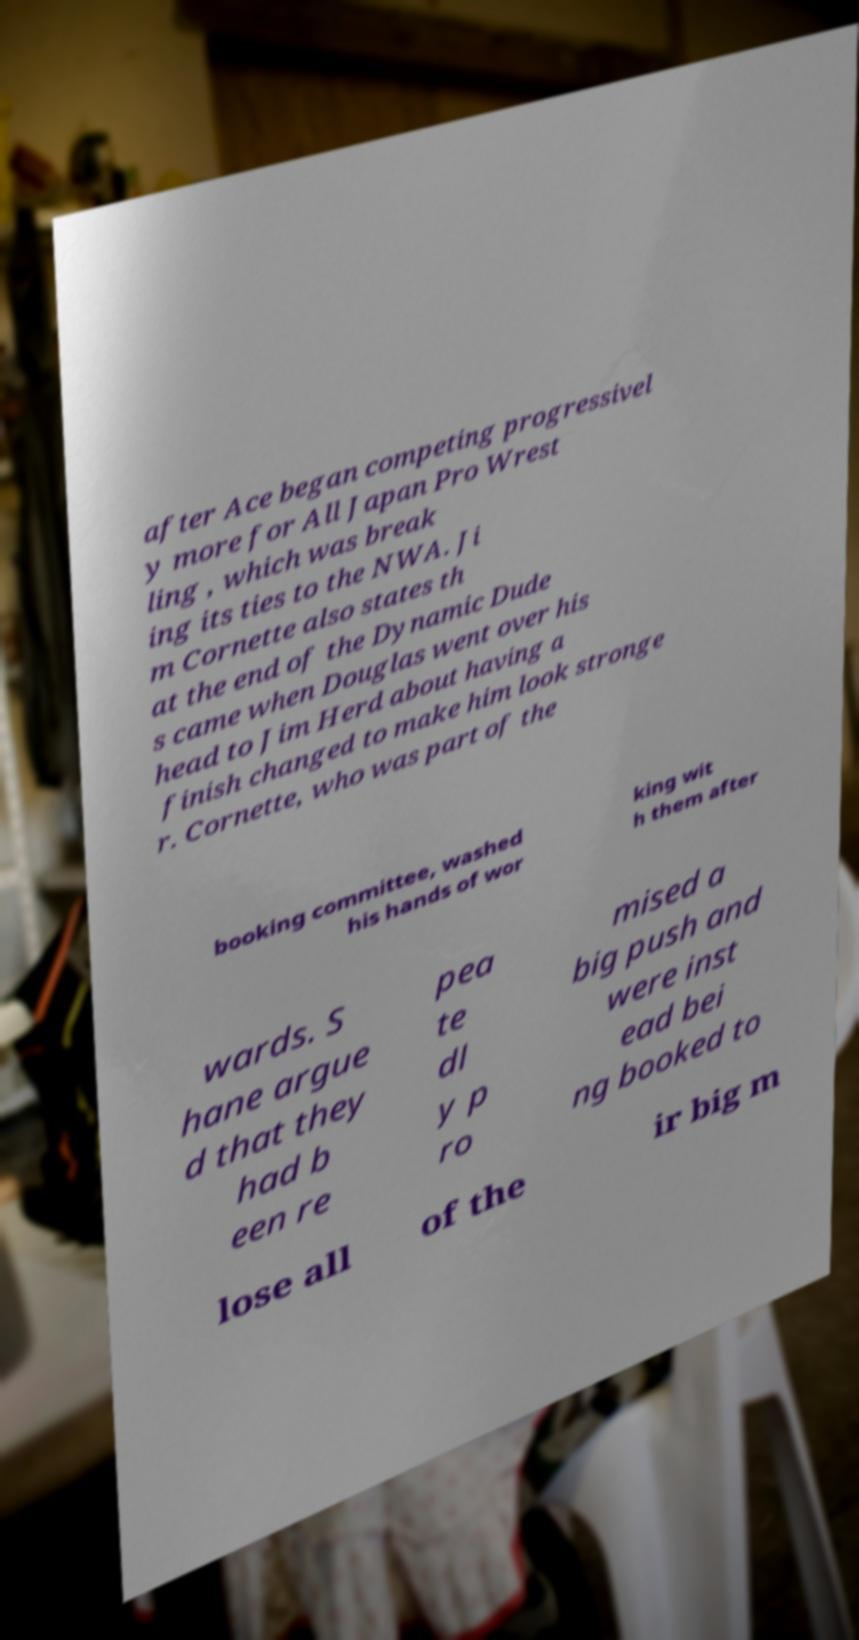Please identify and transcribe the text found in this image. after Ace began competing progressivel y more for All Japan Pro Wrest ling , which was break ing its ties to the NWA. Ji m Cornette also states th at the end of the Dynamic Dude s came when Douglas went over his head to Jim Herd about having a finish changed to make him look stronge r. Cornette, who was part of the booking committee, washed his hands of wor king wit h them after wards. S hane argue d that they had b een re pea te dl y p ro mised a big push and were inst ead bei ng booked to lose all of the ir big m 